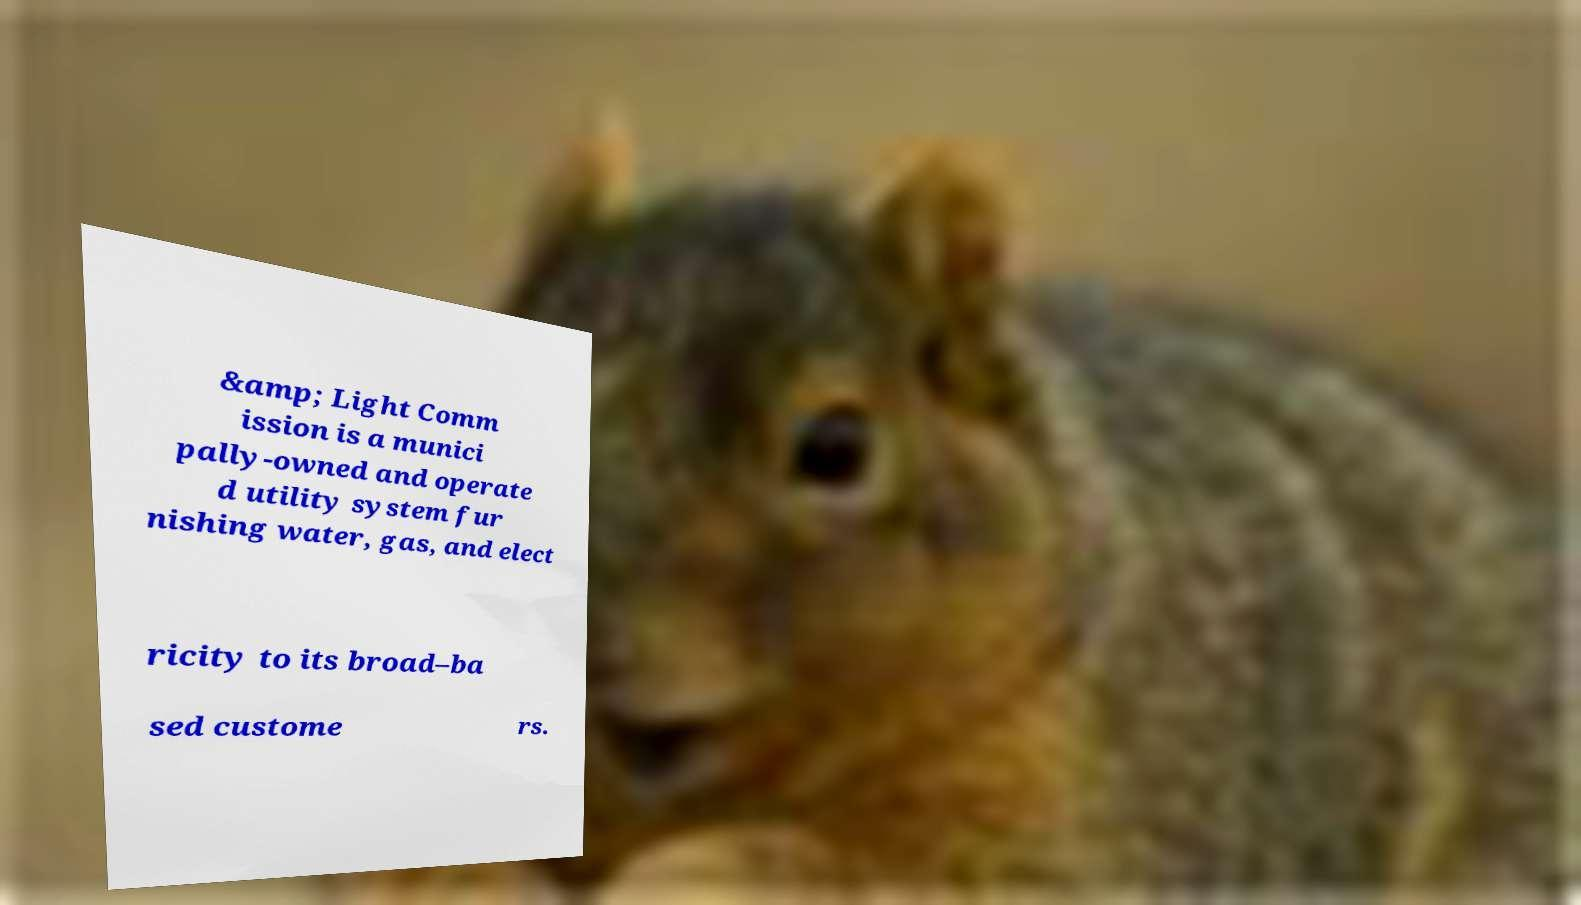There's text embedded in this image that I need extracted. Can you transcribe it verbatim? &amp; Light Comm ission is a munici pally-owned and operate d utility system fur nishing water, gas, and elect ricity to its broad–ba sed custome rs. 